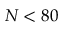<formula> <loc_0><loc_0><loc_500><loc_500>N < 8 0</formula> 